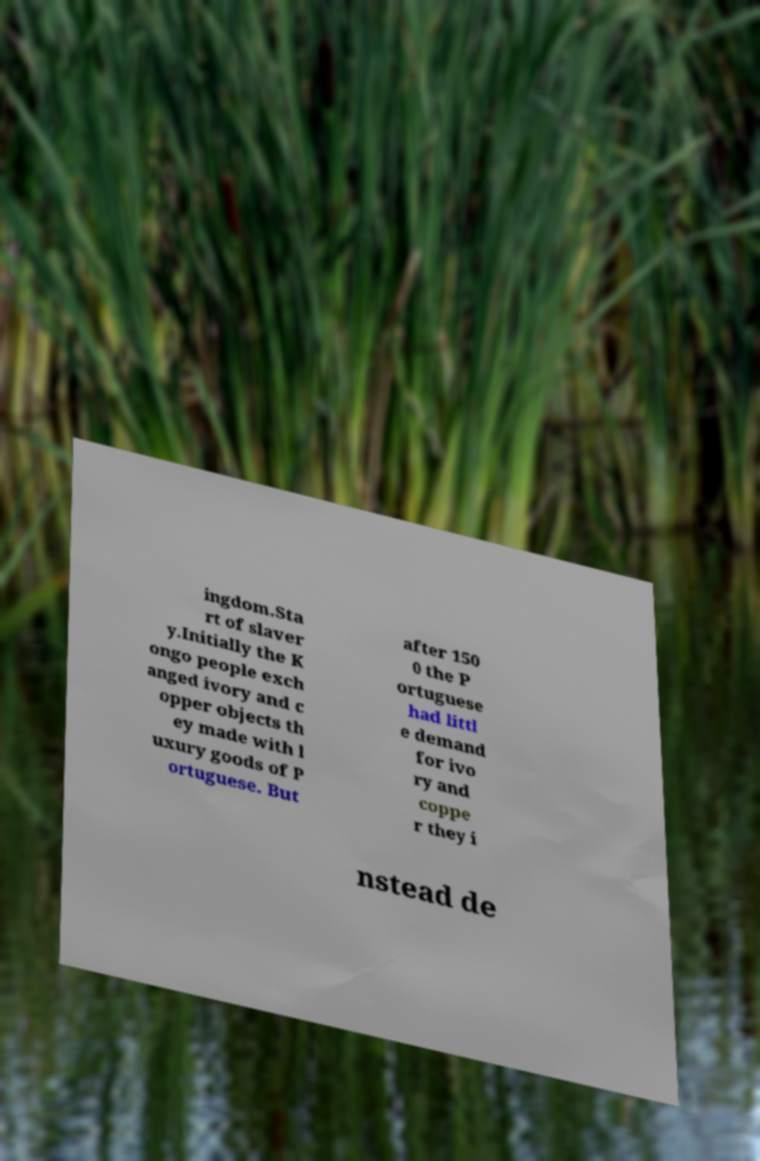Can you accurately transcribe the text from the provided image for me? ingdom.Sta rt of slaver y.Initially the K ongo people exch anged ivory and c opper objects th ey made with l uxury goods of P ortuguese. But after 150 0 the P ortuguese had littl e demand for ivo ry and coppe r they i nstead de 